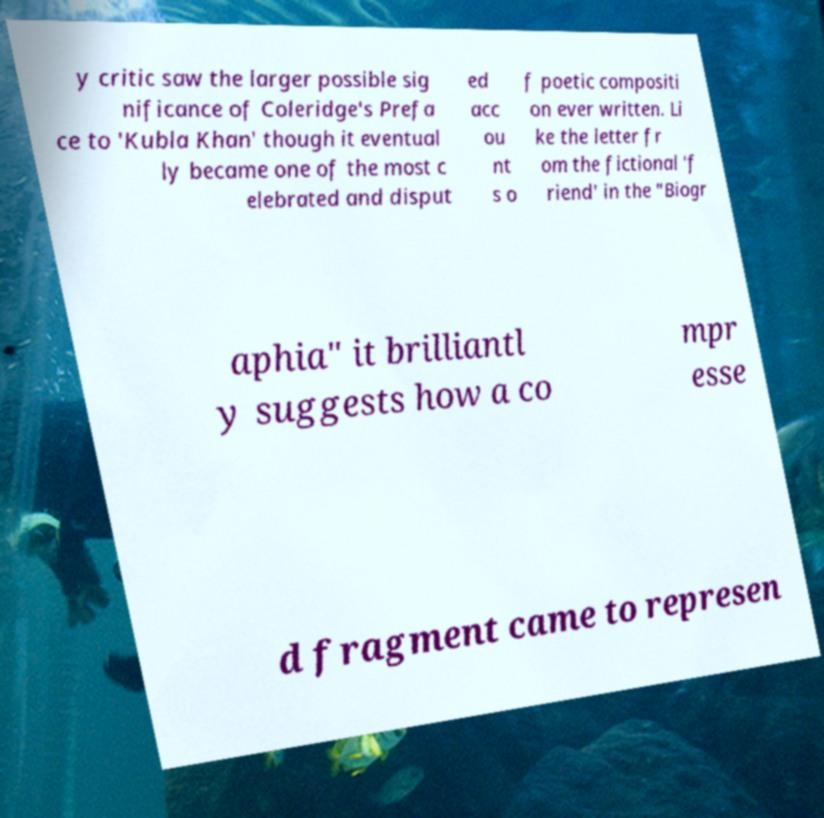Please identify and transcribe the text found in this image. y critic saw the larger possible sig nificance of Coleridge's Prefa ce to 'Kubla Khan' though it eventual ly became one of the most c elebrated and disput ed acc ou nt s o f poetic compositi on ever written. Li ke the letter fr om the fictional 'f riend' in the "Biogr aphia" it brilliantl y suggests how a co mpr esse d fragment came to represen 